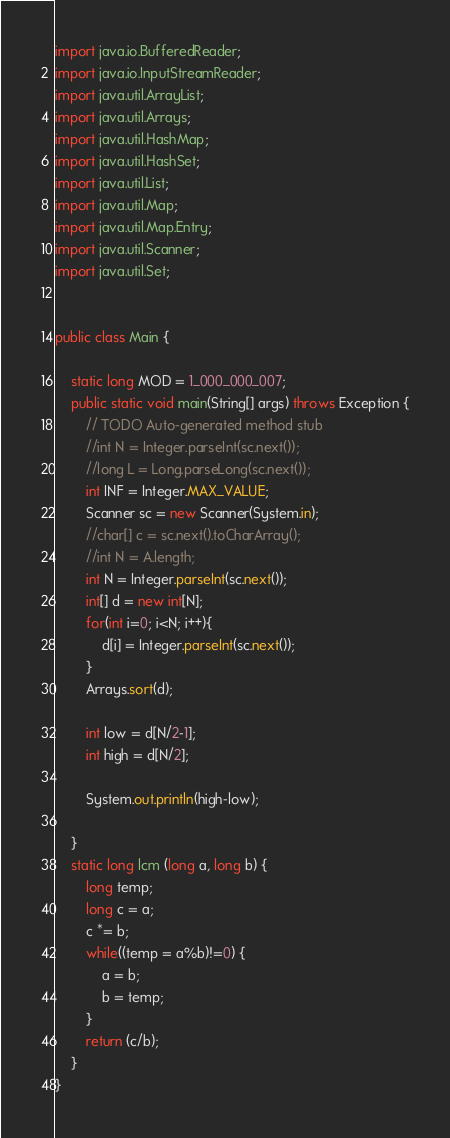Convert code to text. <code><loc_0><loc_0><loc_500><loc_500><_Java_>import java.io.BufferedReader;
import java.io.InputStreamReader;
import java.util.ArrayList;
import java.util.Arrays;
import java.util.HashMap;
import java.util.HashSet;
import java.util.List;
import java.util.Map;
import java.util.Map.Entry;
import java.util.Scanner;
import java.util.Set;
 
 
public class Main {

	static long MOD = 1_000_000_007;
	public static void main(String[] args) throws Exception {
		// TODO Auto-generated method stub
		//int N = Integer.parseInt(sc.next());
		//long L = Long.parseLong(sc.next());
		int INF = Integer.MAX_VALUE;
		Scanner sc = new Scanner(System.in);
		//char[] c = sc.next().toCharArray();
		//int N = A.length;
		int N = Integer.parseInt(sc.next());
		int[] d = new int[N];
		for(int i=0; i<N; i++){
			d[i] = Integer.parseInt(sc.next());
		}
		Arrays.sort(d);
		
		int low = d[N/2-1];
		int high = d[N/2];
		
		System.out.println(high-low);
		
	}
	static long lcm (long a, long b) {
		long temp;
		long c = a;
		c *= b;
		while((temp = a%b)!=0) {
			a = b;
			b = temp;
		}
		return (c/b);
	}
}

</code> 